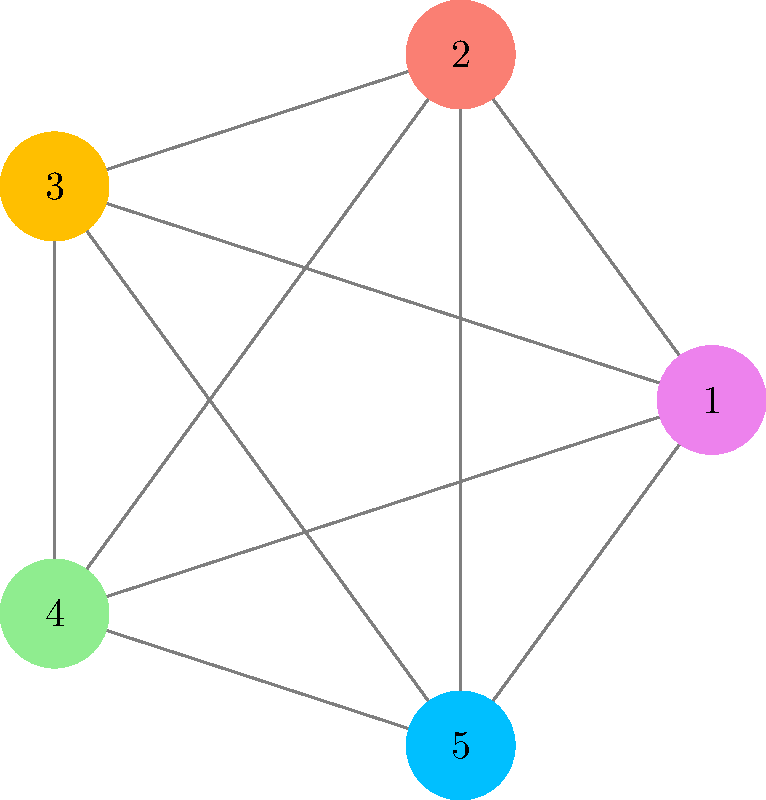In the circular arrangement of color nodes shown above, inspired by van Gogh's vibrant palette, each node represents a unique color. The goal is to find the optimal arrangement that minimizes the total chromatic difference between adjacent colors. If the chromatic difference between two colors is represented by the number of edges between them, what is the sum of the chromatic differences in the current arrangement? To solve this problem, we need to follow these steps:

1. Identify adjacent colors in the circular arrangement:
   1-2, 2-3, 3-4, 4-5, and 5-1

2. Count the number of edges between each adjacent pair:
   1-2: 1 edge
   2-3: 1 edge
   3-4: 1 edge
   4-5: 1 edge
   5-1: 1 edge

3. Sum up all the chromatic differences:
   $1 + 1 + 1 + 1 + 1 = 5$

The current arrangement is actually optimal, as it minimizes the total chromatic difference. This circular layout is reminiscent of van Gogh's color wheel studies, where he explored the relationships between complementary colors to create harmony and contrast in his paintings.
Answer: 5 